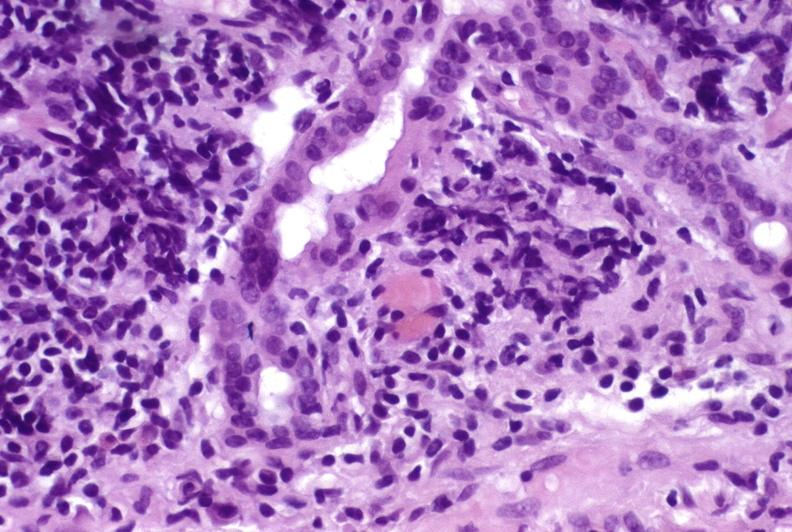what does this image show?
Answer the question using a single word or phrase. Recurrent hepatitis c virus 